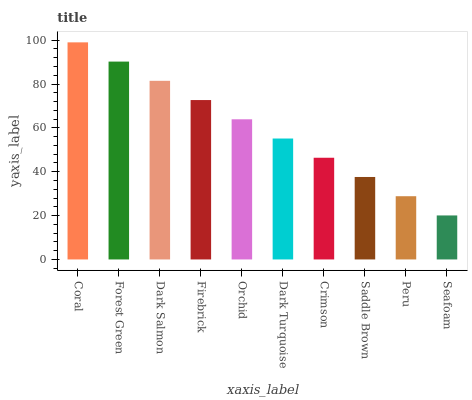Is Forest Green the minimum?
Answer yes or no. No. Is Forest Green the maximum?
Answer yes or no. No. Is Coral greater than Forest Green?
Answer yes or no. Yes. Is Forest Green less than Coral?
Answer yes or no. Yes. Is Forest Green greater than Coral?
Answer yes or no. No. Is Coral less than Forest Green?
Answer yes or no. No. Is Orchid the high median?
Answer yes or no. Yes. Is Dark Turquoise the low median?
Answer yes or no. Yes. Is Dark Turquoise the high median?
Answer yes or no. No. Is Forest Green the low median?
Answer yes or no. No. 